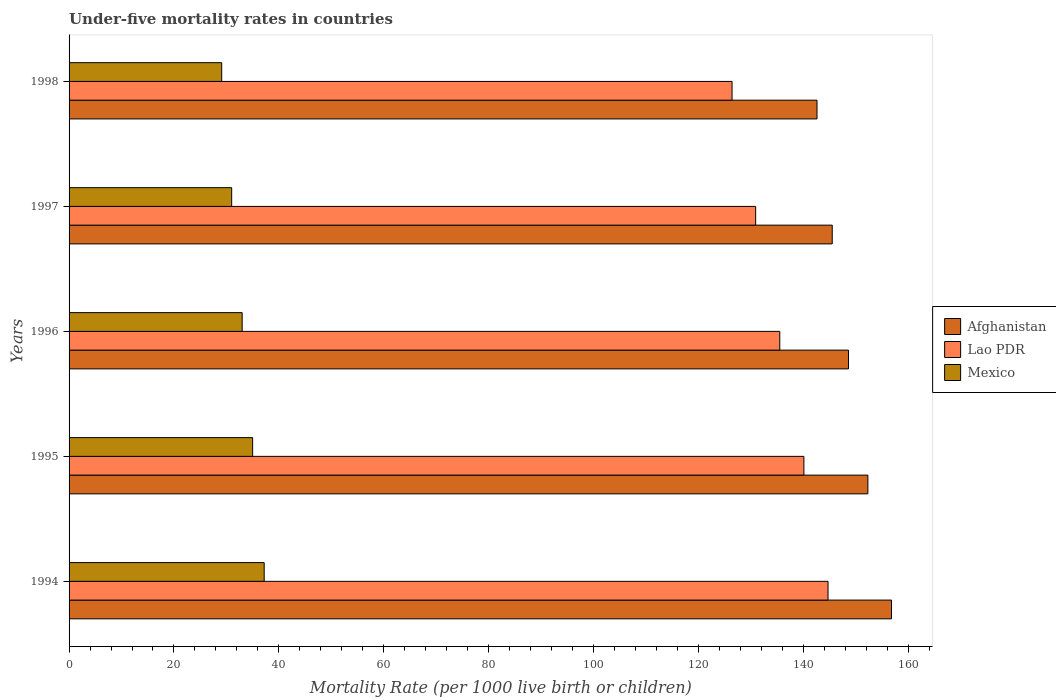How many different coloured bars are there?
Offer a very short reply. 3. Are the number of bars per tick equal to the number of legend labels?
Make the answer very short. Yes. Are the number of bars on each tick of the Y-axis equal?
Offer a very short reply. Yes. How many bars are there on the 2nd tick from the bottom?
Offer a very short reply. 3. In how many cases, is the number of bars for a given year not equal to the number of legend labels?
Your answer should be compact. 0. What is the under-five mortality rate in Afghanistan in 1995?
Ensure brevity in your answer.  152.3. Across all years, what is the maximum under-five mortality rate in Mexico?
Make the answer very short. 37.2. Across all years, what is the minimum under-five mortality rate in Mexico?
Provide a short and direct response. 29.1. In which year was the under-five mortality rate in Mexico minimum?
Provide a succinct answer. 1998. What is the total under-five mortality rate in Mexico in the graph?
Your answer should be compact. 165.3. What is the difference between the under-five mortality rate in Lao PDR in 1997 and that in 1998?
Ensure brevity in your answer.  4.5. What is the difference between the under-five mortality rate in Lao PDR in 1997 and the under-five mortality rate in Mexico in 1998?
Your answer should be compact. 101.8. What is the average under-five mortality rate in Lao PDR per year?
Your response must be concise. 135.52. In the year 1998, what is the difference between the under-five mortality rate in Mexico and under-five mortality rate in Lao PDR?
Offer a terse response. -97.3. What is the ratio of the under-five mortality rate in Mexico in 1994 to that in 1996?
Offer a terse response. 1.13. Is the under-five mortality rate in Afghanistan in 1995 less than that in 1996?
Provide a succinct answer. No. Is the difference between the under-five mortality rate in Mexico in 1995 and 1998 greater than the difference between the under-five mortality rate in Lao PDR in 1995 and 1998?
Offer a terse response. No. What is the difference between the highest and the second highest under-five mortality rate in Lao PDR?
Ensure brevity in your answer.  4.6. What is the difference between the highest and the lowest under-five mortality rate in Afghanistan?
Offer a very short reply. 14.2. What does the 3rd bar from the bottom in 1995 represents?
Offer a terse response. Mexico. How many bars are there?
Provide a short and direct response. 15. What is the difference between two consecutive major ticks on the X-axis?
Your response must be concise. 20. Does the graph contain grids?
Your response must be concise. No. How many legend labels are there?
Provide a succinct answer. 3. What is the title of the graph?
Offer a terse response. Under-five mortality rates in countries. What is the label or title of the X-axis?
Your answer should be very brief. Mortality Rate (per 1000 live birth or children). What is the label or title of the Y-axis?
Keep it short and to the point. Years. What is the Mortality Rate (per 1000 live birth or children) of Afghanistan in 1994?
Your answer should be very brief. 156.8. What is the Mortality Rate (per 1000 live birth or children) in Lao PDR in 1994?
Ensure brevity in your answer.  144.7. What is the Mortality Rate (per 1000 live birth or children) in Mexico in 1994?
Ensure brevity in your answer.  37.2. What is the Mortality Rate (per 1000 live birth or children) of Afghanistan in 1995?
Give a very brief answer. 152.3. What is the Mortality Rate (per 1000 live birth or children) of Lao PDR in 1995?
Make the answer very short. 140.1. What is the Mortality Rate (per 1000 live birth or children) of Afghanistan in 1996?
Give a very brief answer. 148.6. What is the Mortality Rate (per 1000 live birth or children) in Lao PDR in 1996?
Offer a terse response. 135.5. What is the Mortality Rate (per 1000 live birth or children) of Mexico in 1996?
Ensure brevity in your answer.  33. What is the Mortality Rate (per 1000 live birth or children) in Afghanistan in 1997?
Offer a very short reply. 145.5. What is the Mortality Rate (per 1000 live birth or children) in Lao PDR in 1997?
Keep it short and to the point. 130.9. What is the Mortality Rate (per 1000 live birth or children) in Mexico in 1997?
Provide a succinct answer. 31. What is the Mortality Rate (per 1000 live birth or children) of Afghanistan in 1998?
Your answer should be very brief. 142.6. What is the Mortality Rate (per 1000 live birth or children) in Lao PDR in 1998?
Offer a very short reply. 126.4. What is the Mortality Rate (per 1000 live birth or children) of Mexico in 1998?
Provide a succinct answer. 29.1. Across all years, what is the maximum Mortality Rate (per 1000 live birth or children) of Afghanistan?
Offer a very short reply. 156.8. Across all years, what is the maximum Mortality Rate (per 1000 live birth or children) in Lao PDR?
Your response must be concise. 144.7. Across all years, what is the maximum Mortality Rate (per 1000 live birth or children) in Mexico?
Offer a very short reply. 37.2. Across all years, what is the minimum Mortality Rate (per 1000 live birth or children) of Afghanistan?
Keep it short and to the point. 142.6. Across all years, what is the minimum Mortality Rate (per 1000 live birth or children) in Lao PDR?
Provide a short and direct response. 126.4. Across all years, what is the minimum Mortality Rate (per 1000 live birth or children) in Mexico?
Your answer should be compact. 29.1. What is the total Mortality Rate (per 1000 live birth or children) in Afghanistan in the graph?
Provide a succinct answer. 745.8. What is the total Mortality Rate (per 1000 live birth or children) of Lao PDR in the graph?
Offer a terse response. 677.6. What is the total Mortality Rate (per 1000 live birth or children) in Mexico in the graph?
Ensure brevity in your answer.  165.3. What is the difference between the Mortality Rate (per 1000 live birth or children) in Afghanistan in 1994 and that in 1995?
Offer a very short reply. 4.5. What is the difference between the Mortality Rate (per 1000 live birth or children) in Lao PDR in 1994 and that in 1995?
Give a very brief answer. 4.6. What is the difference between the Mortality Rate (per 1000 live birth or children) of Lao PDR in 1994 and that in 1996?
Ensure brevity in your answer.  9.2. What is the difference between the Mortality Rate (per 1000 live birth or children) in Mexico in 1994 and that in 1996?
Make the answer very short. 4.2. What is the difference between the Mortality Rate (per 1000 live birth or children) in Afghanistan in 1994 and that in 1997?
Offer a very short reply. 11.3. What is the difference between the Mortality Rate (per 1000 live birth or children) in Mexico in 1994 and that in 1997?
Your response must be concise. 6.2. What is the difference between the Mortality Rate (per 1000 live birth or children) of Mexico in 1994 and that in 1998?
Offer a terse response. 8.1. What is the difference between the Mortality Rate (per 1000 live birth or children) of Afghanistan in 1995 and that in 1996?
Your answer should be very brief. 3.7. What is the difference between the Mortality Rate (per 1000 live birth or children) of Afghanistan in 1995 and that in 1997?
Keep it short and to the point. 6.8. What is the difference between the Mortality Rate (per 1000 live birth or children) of Mexico in 1995 and that in 1997?
Your response must be concise. 4. What is the difference between the Mortality Rate (per 1000 live birth or children) of Afghanistan in 1995 and that in 1998?
Make the answer very short. 9.7. What is the difference between the Mortality Rate (per 1000 live birth or children) of Mexico in 1995 and that in 1998?
Make the answer very short. 5.9. What is the difference between the Mortality Rate (per 1000 live birth or children) in Lao PDR in 1996 and that in 1997?
Give a very brief answer. 4.6. What is the difference between the Mortality Rate (per 1000 live birth or children) in Afghanistan in 1996 and that in 1998?
Your response must be concise. 6. What is the difference between the Mortality Rate (per 1000 live birth or children) of Mexico in 1996 and that in 1998?
Provide a succinct answer. 3.9. What is the difference between the Mortality Rate (per 1000 live birth or children) in Afghanistan in 1997 and that in 1998?
Provide a short and direct response. 2.9. What is the difference between the Mortality Rate (per 1000 live birth or children) in Lao PDR in 1997 and that in 1998?
Offer a terse response. 4.5. What is the difference between the Mortality Rate (per 1000 live birth or children) in Mexico in 1997 and that in 1998?
Give a very brief answer. 1.9. What is the difference between the Mortality Rate (per 1000 live birth or children) in Afghanistan in 1994 and the Mortality Rate (per 1000 live birth or children) in Mexico in 1995?
Provide a short and direct response. 121.8. What is the difference between the Mortality Rate (per 1000 live birth or children) in Lao PDR in 1994 and the Mortality Rate (per 1000 live birth or children) in Mexico in 1995?
Give a very brief answer. 109.7. What is the difference between the Mortality Rate (per 1000 live birth or children) in Afghanistan in 1994 and the Mortality Rate (per 1000 live birth or children) in Lao PDR in 1996?
Ensure brevity in your answer.  21.3. What is the difference between the Mortality Rate (per 1000 live birth or children) in Afghanistan in 1994 and the Mortality Rate (per 1000 live birth or children) in Mexico in 1996?
Your answer should be very brief. 123.8. What is the difference between the Mortality Rate (per 1000 live birth or children) of Lao PDR in 1994 and the Mortality Rate (per 1000 live birth or children) of Mexico in 1996?
Your answer should be compact. 111.7. What is the difference between the Mortality Rate (per 1000 live birth or children) in Afghanistan in 1994 and the Mortality Rate (per 1000 live birth or children) in Lao PDR in 1997?
Your answer should be very brief. 25.9. What is the difference between the Mortality Rate (per 1000 live birth or children) of Afghanistan in 1994 and the Mortality Rate (per 1000 live birth or children) of Mexico in 1997?
Make the answer very short. 125.8. What is the difference between the Mortality Rate (per 1000 live birth or children) of Lao PDR in 1994 and the Mortality Rate (per 1000 live birth or children) of Mexico in 1997?
Offer a very short reply. 113.7. What is the difference between the Mortality Rate (per 1000 live birth or children) of Afghanistan in 1994 and the Mortality Rate (per 1000 live birth or children) of Lao PDR in 1998?
Provide a succinct answer. 30.4. What is the difference between the Mortality Rate (per 1000 live birth or children) of Afghanistan in 1994 and the Mortality Rate (per 1000 live birth or children) of Mexico in 1998?
Offer a terse response. 127.7. What is the difference between the Mortality Rate (per 1000 live birth or children) of Lao PDR in 1994 and the Mortality Rate (per 1000 live birth or children) of Mexico in 1998?
Make the answer very short. 115.6. What is the difference between the Mortality Rate (per 1000 live birth or children) of Afghanistan in 1995 and the Mortality Rate (per 1000 live birth or children) of Mexico in 1996?
Provide a short and direct response. 119.3. What is the difference between the Mortality Rate (per 1000 live birth or children) of Lao PDR in 1995 and the Mortality Rate (per 1000 live birth or children) of Mexico in 1996?
Make the answer very short. 107.1. What is the difference between the Mortality Rate (per 1000 live birth or children) of Afghanistan in 1995 and the Mortality Rate (per 1000 live birth or children) of Lao PDR in 1997?
Make the answer very short. 21.4. What is the difference between the Mortality Rate (per 1000 live birth or children) of Afghanistan in 1995 and the Mortality Rate (per 1000 live birth or children) of Mexico in 1997?
Your answer should be compact. 121.3. What is the difference between the Mortality Rate (per 1000 live birth or children) of Lao PDR in 1995 and the Mortality Rate (per 1000 live birth or children) of Mexico in 1997?
Keep it short and to the point. 109.1. What is the difference between the Mortality Rate (per 1000 live birth or children) in Afghanistan in 1995 and the Mortality Rate (per 1000 live birth or children) in Lao PDR in 1998?
Offer a very short reply. 25.9. What is the difference between the Mortality Rate (per 1000 live birth or children) in Afghanistan in 1995 and the Mortality Rate (per 1000 live birth or children) in Mexico in 1998?
Ensure brevity in your answer.  123.2. What is the difference between the Mortality Rate (per 1000 live birth or children) in Lao PDR in 1995 and the Mortality Rate (per 1000 live birth or children) in Mexico in 1998?
Your answer should be compact. 111. What is the difference between the Mortality Rate (per 1000 live birth or children) of Afghanistan in 1996 and the Mortality Rate (per 1000 live birth or children) of Mexico in 1997?
Your answer should be compact. 117.6. What is the difference between the Mortality Rate (per 1000 live birth or children) of Lao PDR in 1996 and the Mortality Rate (per 1000 live birth or children) of Mexico in 1997?
Offer a terse response. 104.5. What is the difference between the Mortality Rate (per 1000 live birth or children) of Afghanistan in 1996 and the Mortality Rate (per 1000 live birth or children) of Lao PDR in 1998?
Provide a short and direct response. 22.2. What is the difference between the Mortality Rate (per 1000 live birth or children) of Afghanistan in 1996 and the Mortality Rate (per 1000 live birth or children) of Mexico in 1998?
Give a very brief answer. 119.5. What is the difference between the Mortality Rate (per 1000 live birth or children) of Lao PDR in 1996 and the Mortality Rate (per 1000 live birth or children) of Mexico in 1998?
Make the answer very short. 106.4. What is the difference between the Mortality Rate (per 1000 live birth or children) in Afghanistan in 1997 and the Mortality Rate (per 1000 live birth or children) in Mexico in 1998?
Provide a succinct answer. 116.4. What is the difference between the Mortality Rate (per 1000 live birth or children) in Lao PDR in 1997 and the Mortality Rate (per 1000 live birth or children) in Mexico in 1998?
Provide a short and direct response. 101.8. What is the average Mortality Rate (per 1000 live birth or children) of Afghanistan per year?
Provide a succinct answer. 149.16. What is the average Mortality Rate (per 1000 live birth or children) of Lao PDR per year?
Ensure brevity in your answer.  135.52. What is the average Mortality Rate (per 1000 live birth or children) in Mexico per year?
Keep it short and to the point. 33.06. In the year 1994, what is the difference between the Mortality Rate (per 1000 live birth or children) in Afghanistan and Mortality Rate (per 1000 live birth or children) in Lao PDR?
Provide a succinct answer. 12.1. In the year 1994, what is the difference between the Mortality Rate (per 1000 live birth or children) of Afghanistan and Mortality Rate (per 1000 live birth or children) of Mexico?
Make the answer very short. 119.6. In the year 1994, what is the difference between the Mortality Rate (per 1000 live birth or children) of Lao PDR and Mortality Rate (per 1000 live birth or children) of Mexico?
Offer a very short reply. 107.5. In the year 1995, what is the difference between the Mortality Rate (per 1000 live birth or children) in Afghanistan and Mortality Rate (per 1000 live birth or children) in Mexico?
Keep it short and to the point. 117.3. In the year 1995, what is the difference between the Mortality Rate (per 1000 live birth or children) of Lao PDR and Mortality Rate (per 1000 live birth or children) of Mexico?
Make the answer very short. 105.1. In the year 1996, what is the difference between the Mortality Rate (per 1000 live birth or children) of Afghanistan and Mortality Rate (per 1000 live birth or children) of Lao PDR?
Give a very brief answer. 13.1. In the year 1996, what is the difference between the Mortality Rate (per 1000 live birth or children) in Afghanistan and Mortality Rate (per 1000 live birth or children) in Mexico?
Offer a terse response. 115.6. In the year 1996, what is the difference between the Mortality Rate (per 1000 live birth or children) of Lao PDR and Mortality Rate (per 1000 live birth or children) of Mexico?
Your answer should be very brief. 102.5. In the year 1997, what is the difference between the Mortality Rate (per 1000 live birth or children) in Afghanistan and Mortality Rate (per 1000 live birth or children) in Mexico?
Ensure brevity in your answer.  114.5. In the year 1997, what is the difference between the Mortality Rate (per 1000 live birth or children) in Lao PDR and Mortality Rate (per 1000 live birth or children) in Mexico?
Keep it short and to the point. 99.9. In the year 1998, what is the difference between the Mortality Rate (per 1000 live birth or children) in Afghanistan and Mortality Rate (per 1000 live birth or children) in Lao PDR?
Ensure brevity in your answer.  16.2. In the year 1998, what is the difference between the Mortality Rate (per 1000 live birth or children) in Afghanistan and Mortality Rate (per 1000 live birth or children) in Mexico?
Provide a succinct answer. 113.5. In the year 1998, what is the difference between the Mortality Rate (per 1000 live birth or children) in Lao PDR and Mortality Rate (per 1000 live birth or children) in Mexico?
Give a very brief answer. 97.3. What is the ratio of the Mortality Rate (per 1000 live birth or children) in Afghanistan in 1994 to that in 1995?
Give a very brief answer. 1.03. What is the ratio of the Mortality Rate (per 1000 live birth or children) of Lao PDR in 1994 to that in 1995?
Your response must be concise. 1.03. What is the ratio of the Mortality Rate (per 1000 live birth or children) in Mexico in 1994 to that in 1995?
Give a very brief answer. 1.06. What is the ratio of the Mortality Rate (per 1000 live birth or children) in Afghanistan in 1994 to that in 1996?
Your answer should be very brief. 1.06. What is the ratio of the Mortality Rate (per 1000 live birth or children) in Lao PDR in 1994 to that in 1996?
Offer a terse response. 1.07. What is the ratio of the Mortality Rate (per 1000 live birth or children) in Mexico in 1994 to that in 1996?
Provide a succinct answer. 1.13. What is the ratio of the Mortality Rate (per 1000 live birth or children) of Afghanistan in 1994 to that in 1997?
Offer a terse response. 1.08. What is the ratio of the Mortality Rate (per 1000 live birth or children) of Lao PDR in 1994 to that in 1997?
Your response must be concise. 1.11. What is the ratio of the Mortality Rate (per 1000 live birth or children) of Afghanistan in 1994 to that in 1998?
Your response must be concise. 1.1. What is the ratio of the Mortality Rate (per 1000 live birth or children) in Lao PDR in 1994 to that in 1998?
Offer a very short reply. 1.14. What is the ratio of the Mortality Rate (per 1000 live birth or children) of Mexico in 1994 to that in 1998?
Provide a succinct answer. 1.28. What is the ratio of the Mortality Rate (per 1000 live birth or children) in Afghanistan in 1995 to that in 1996?
Your answer should be very brief. 1.02. What is the ratio of the Mortality Rate (per 1000 live birth or children) in Lao PDR in 1995 to that in 1996?
Your answer should be very brief. 1.03. What is the ratio of the Mortality Rate (per 1000 live birth or children) of Mexico in 1995 to that in 1996?
Your answer should be very brief. 1.06. What is the ratio of the Mortality Rate (per 1000 live birth or children) in Afghanistan in 1995 to that in 1997?
Offer a very short reply. 1.05. What is the ratio of the Mortality Rate (per 1000 live birth or children) of Lao PDR in 1995 to that in 1997?
Your answer should be compact. 1.07. What is the ratio of the Mortality Rate (per 1000 live birth or children) in Mexico in 1995 to that in 1997?
Provide a short and direct response. 1.13. What is the ratio of the Mortality Rate (per 1000 live birth or children) in Afghanistan in 1995 to that in 1998?
Keep it short and to the point. 1.07. What is the ratio of the Mortality Rate (per 1000 live birth or children) of Lao PDR in 1995 to that in 1998?
Provide a short and direct response. 1.11. What is the ratio of the Mortality Rate (per 1000 live birth or children) in Mexico in 1995 to that in 1998?
Make the answer very short. 1.2. What is the ratio of the Mortality Rate (per 1000 live birth or children) of Afghanistan in 1996 to that in 1997?
Keep it short and to the point. 1.02. What is the ratio of the Mortality Rate (per 1000 live birth or children) in Lao PDR in 1996 to that in 1997?
Give a very brief answer. 1.04. What is the ratio of the Mortality Rate (per 1000 live birth or children) in Mexico in 1996 to that in 1997?
Keep it short and to the point. 1.06. What is the ratio of the Mortality Rate (per 1000 live birth or children) of Afghanistan in 1996 to that in 1998?
Keep it short and to the point. 1.04. What is the ratio of the Mortality Rate (per 1000 live birth or children) of Lao PDR in 1996 to that in 1998?
Offer a terse response. 1.07. What is the ratio of the Mortality Rate (per 1000 live birth or children) in Mexico in 1996 to that in 1998?
Give a very brief answer. 1.13. What is the ratio of the Mortality Rate (per 1000 live birth or children) in Afghanistan in 1997 to that in 1998?
Give a very brief answer. 1.02. What is the ratio of the Mortality Rate (per 1000 live birth or children) in Lao PDR in 1997 to that in 1998?
Provide a succinct answer. 1.04. What is the ratio of the Mortality Rate (per 1000 live birth or children) in Mexico in 1997 to that in 1998?
Your response must be concise. 1.07. What is the difference between the highest and the second highest Mortality Rate (per 1000 live birth or children) in Mexico?
Keep it short and to the point. 2.2. What is the difference between the highest and the lowest Mortality Rate (per 1000 live birth or children) in Afghanistan?
Provide a succinct answer. 14.2. What is the difference between the highest and the lowest Mortality Rate (per 1000 live birth or children) of Lao PDR?
Your answer should be very brief. 18.3. What is the difference between the highest and the lowest Mortality Rate (per 1000 live birth or children) in Mexico?
Provide a succinct answer. 8.1. 